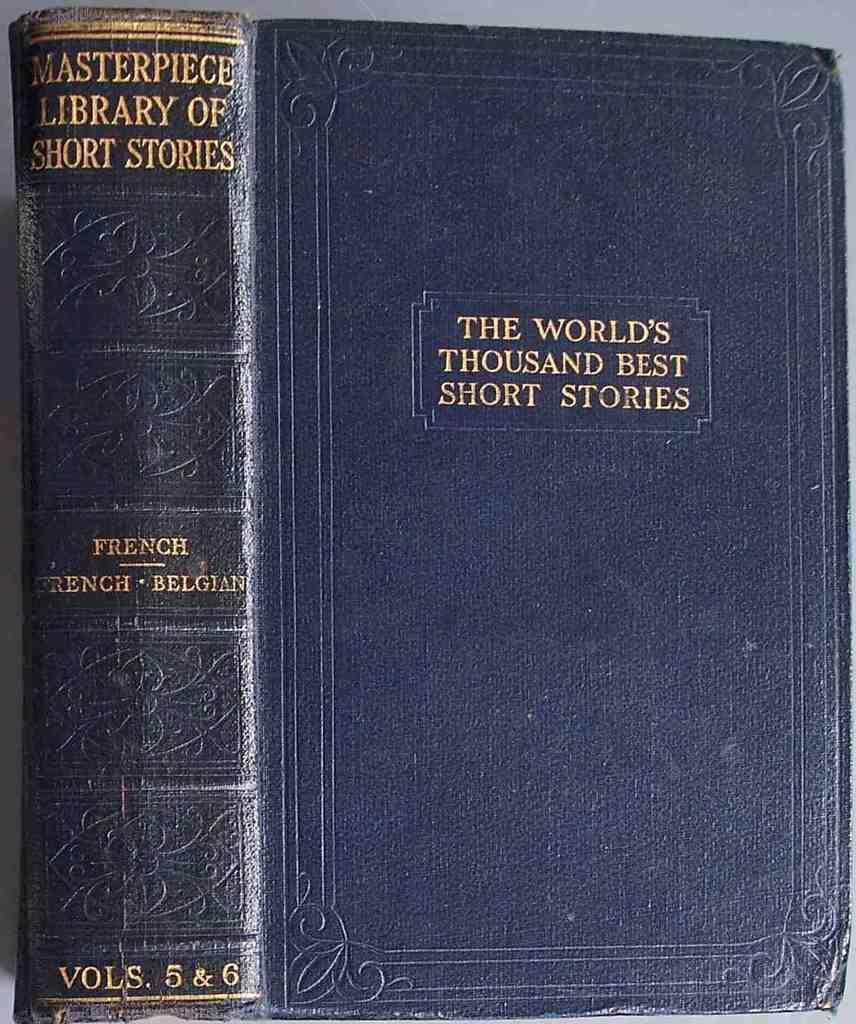<image>
Render a clear and concise summary of the photo. A blue book titled The World's Thousand Best Short Stories. 